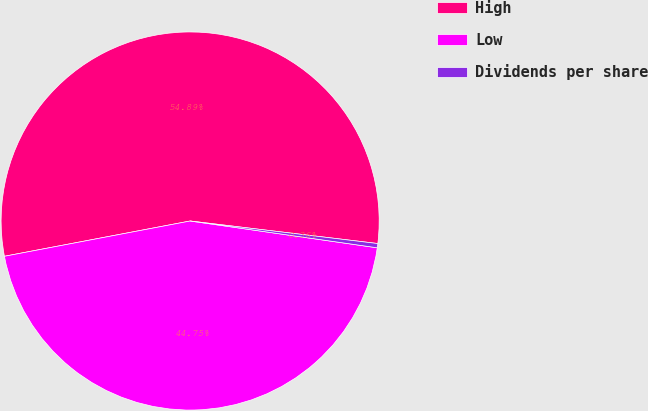<chart> <loc_0><loc_0><loc_500><loc_500><pie_chart><fcel>High<fcel>Low<fcel>Dividends per share<nl><fcel>54.89%<fcel>44.75%<fcel>0.36%<nl></chart> 